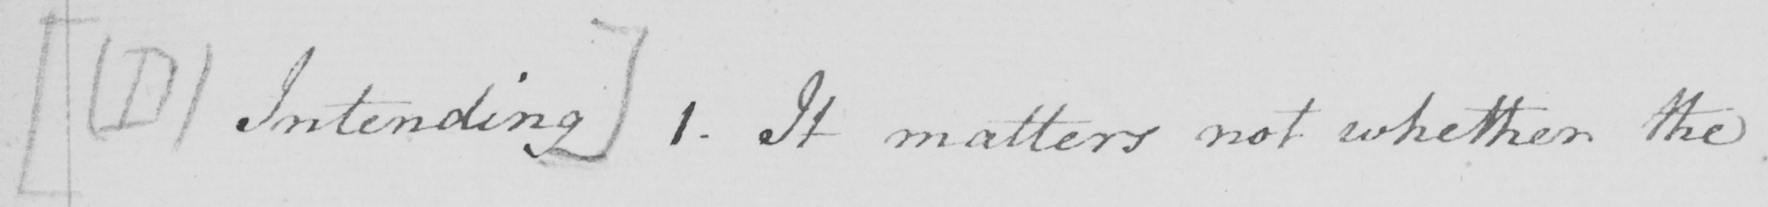What does this handwritten line say? [  ( D ) Intending ]  1 . It matters not whether the 